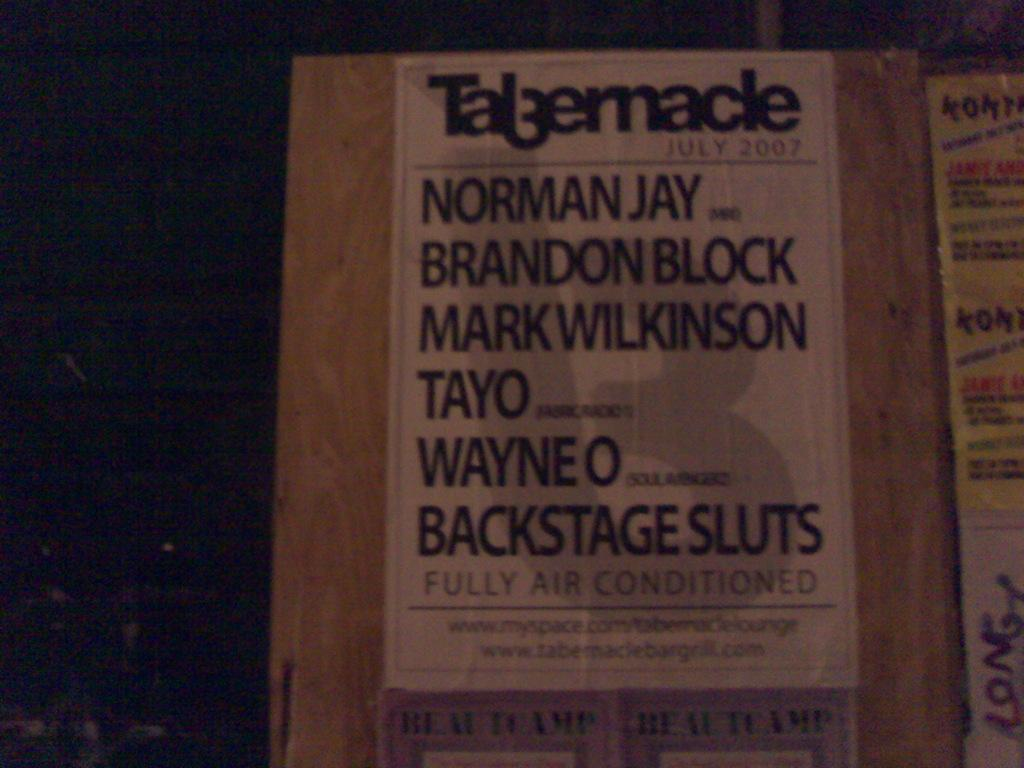What is the color of the board in the image? The board in the image is brown colored. What is attached to the board? There is a white colored poster attached to the board. What can be seen on the poster? There are words written on the poster. What is the color of the background in the image? The background of the image is black. What type of shoe is hanging from the board in the image? There is no shoe present in the image; it features a brown board with a white poster attached. What material is the silk used for the poster in the image? There is no silk mentioned or visible in the image; the poster is white and has words written on it. 